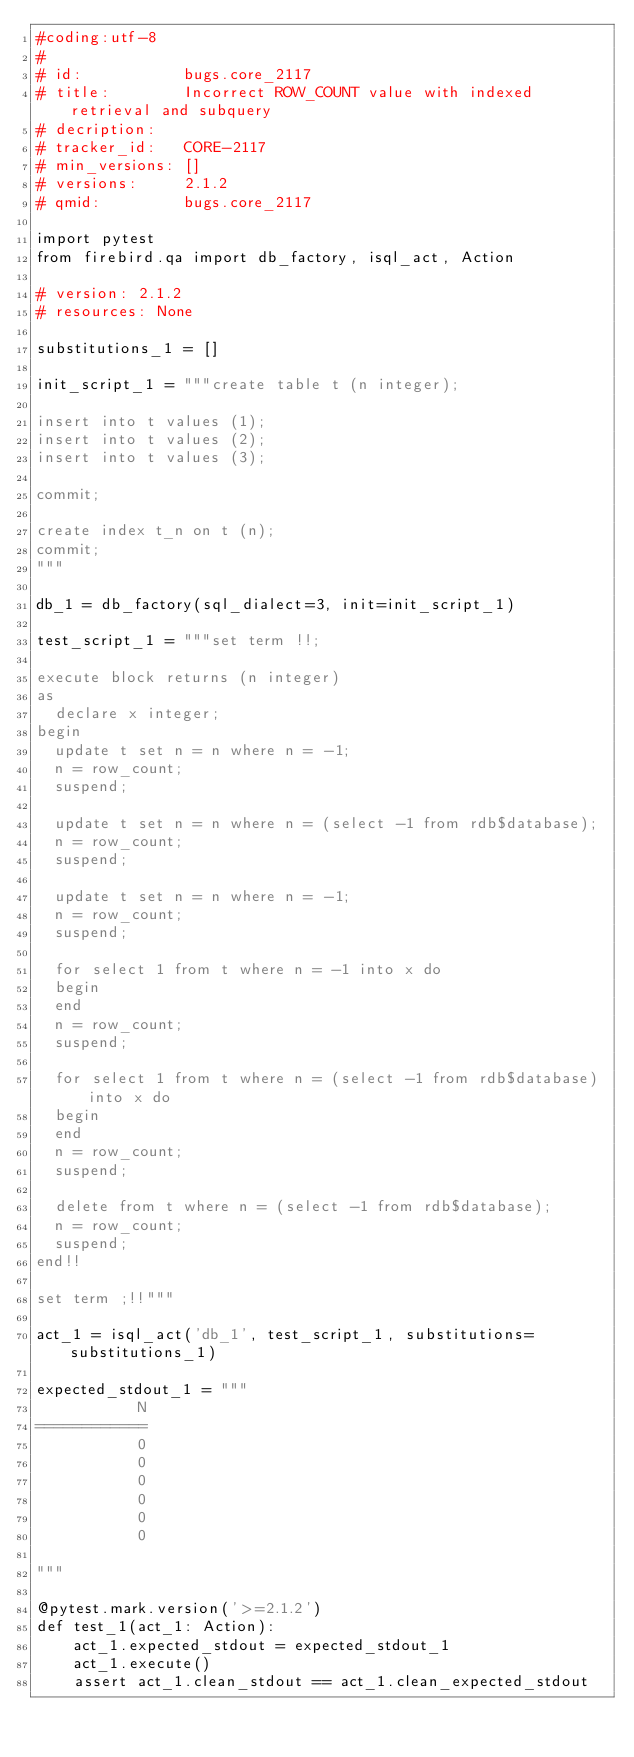<code> <loc_0><loc_0><loc_500><loc_500><_Python_>#coding:utf-8
#
# id:           bugs.core_2117
# title:        Incorrect ROW_COUNT value with indexed retrieval and subquery
# decription:   
# tracker_id:   CORE-2117
# min_versions: []
# versions:     2.1.2
# qmid:         bugs.core_2117

import pytest
from firebird.qa import db_factory, isql_act, Action

# version: 2.1.2
# resources: None

substitutions_1 = []

init_script_1 = """create table t (n integer);

insert into t values (1);
insert into t values (2);
insert into t values (3);

commit;

create index t_n on t (n);
commit;
"""

db_1 = db_factory(sql_dialect=3, init=init_script_1)

test_script_1 = """set term !!;

execute block returns (n integer)
as
  declare x integer;
begin
  update t set n = n where n = -1;
  n = row_count;
  suspend;

  update t set n = n where n = (select -1 from rdb$database);
  n = row_count;
  suspend;

  update t set n = n where n = -1;
  n = row_count;
  suspend;

  for select 1 from t where n = -1 into x do
  begin
  end
  n = row_count;
  suspend;

  for select 1 from t where n = (select -1 from rdb$database) into x do
  begin
  end
  n = row_count;
  suspend;

  delete from t where n = (select -1 from rdb$database);
  n = row_count;
  suspend;
end!!

set term ;!!"""

act_1 = isql_act('db_1', test_script_1, substitutions=substitutions_1)

expected_stdout_1 = """
           N
============
           0
           0
           0
           0
           0
           0

"""

@pytest.mark.version('>=2.1.2')
def test_1(act_1: Action):
    act_1.expected_stdout = expected_stdout_1
    act_1.execute()
    assert act_1.clean_stdout == act_1.clean_expected_stdout

</code> 